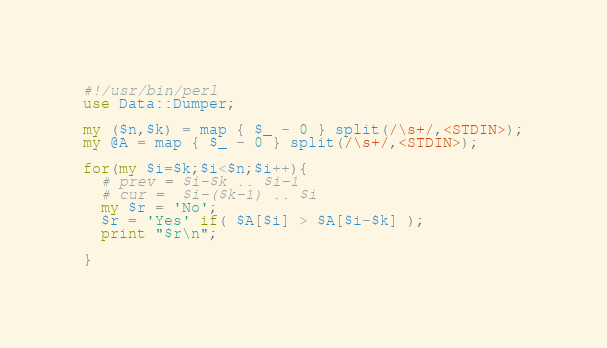Convert code to text. <code><loc_0><loc_0><loc_500><loc_500><_Perl_>#!/usr/bin/perl
use Data::Dumper;

my ($n,$k) = map { $_ - 0 } split(/\s+/,<STDIN>);
my @A = map { $_ - 0 } split(/\s+/,<STDIN>);

for(my $i=$k;$i<$n;$i++){
  # prev = $i-$k .. $i-1 
  # cur =  $i-($k-1) .. $i
  my $r = 'No';
  $r = 'Yes' if( $A[$i] > $A[$i-$k] );
  print "$r\n";
  
}



</code> 